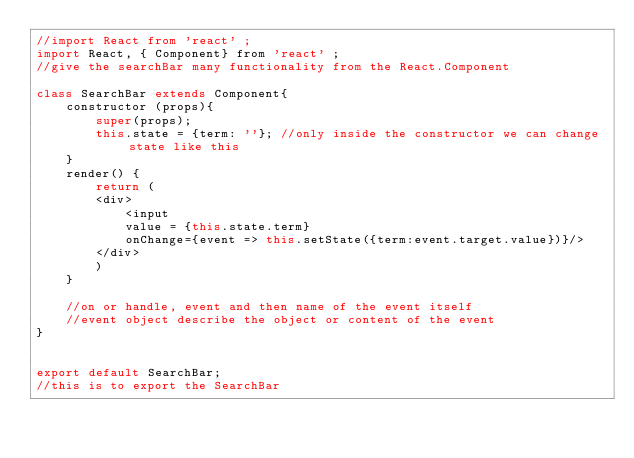Convert code to text. <code><loc_0><loc_0><loc_500><loc_500><_JavaScript_>//import React from 'react' ;
import React, { Component} from 'react' ;
//give the searchBar many functionality from the React.Component

class SearchBar extends Component{
    constructor (props){
        super(props);
        this.state = {term: ''}; //only inside the constructor we can change state like this
    }
    render() {
        return (
        <div>
            <input
            value = {this.state.term}
            onChange={event => this.setState({term:event.target.value})}/>
        </div>
        )
    }

    //on or handle, event and then name of the event itself
    //event object describe the object or content of the event
}


export default SearchBar;
//this is to export the SearchBar</code> 